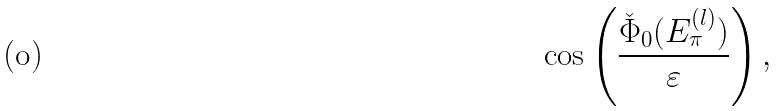<formula> <loc_0><loc_0><loc_500><loc_500>\cos \left ( \frac { \check { \Phi } _ { 0 } ( E _ { \pi } ^ { ( l ) } ) } { \varepsilon } \right ) ,</formula> 